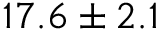Convert formula to latex. <formula><loc_0><loc_0><loc_500><loc_500>1 7 . 6 \pm 2 . 1</formula> 